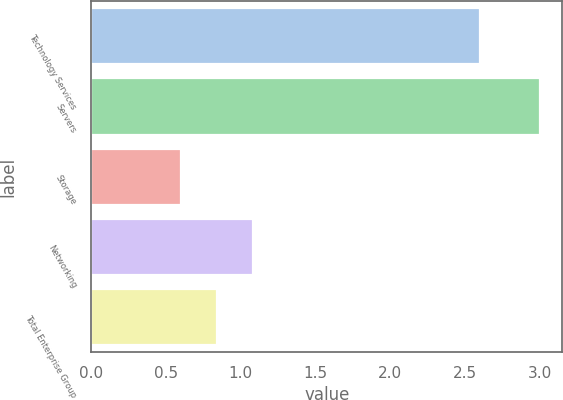Convert chart. <chart><loc_0><loc_0><loc_500><loc_500><bar_chart><fcel>Technology Services<fcel>Servers<fcel>Storage<fcel>Networking<fcel>Total Enterprise Group<nl><fcel>2.6<fcel>3<fcel>0.6<fcel>1.08<fcel>0.84<nl></chart> 